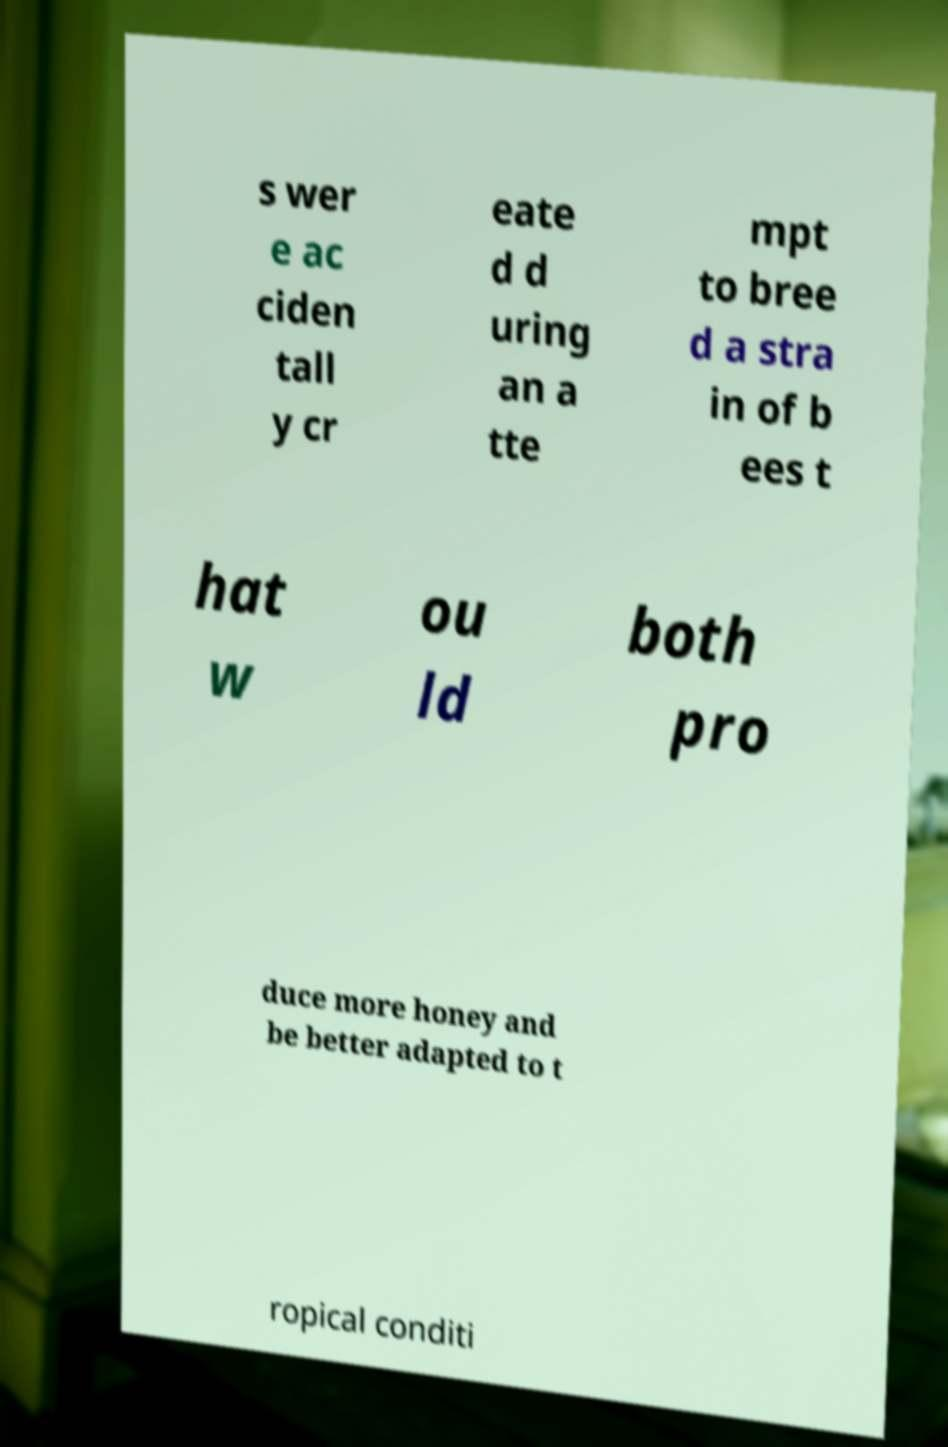I need the written content from this picture converted into text. Can you do that? s wer e ac ciden tall y cr eate d d uring an a tte mpt to bree d a stra in of b ees t hat w ou ld both pro duce more honey and be better adapted to t ropical conditi 